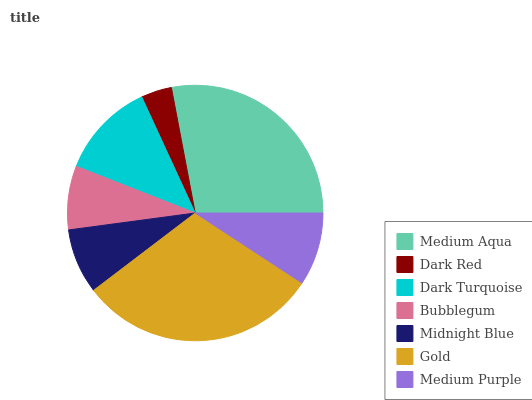Is Dark Red the minimum?
Answer yes or no. Yes. Is Gold the maximum?
Answer yes or no. Yes. Is Dark Turquoise the minimum?
Answer yes or no. No. Is Dark Turquoise the maximum?
Answer yes or no. No. Is Dark Turquoise greater than Dark Red?
Answer yes or no. Yes. Is Dark Red less than Dark Turquoise?
Answer yes or no. Yes. Is Dark Red greater than Dark Turquoise?
Answer yes or no. No. Is Dark Turquoise less than Dark Red?
Answer yes or no. No. Is Medium Purple the high median?
Answer yes or no. Yes. Is Medium Purple the low median?
Answer yes or no. Yes. Is Bubblegum the high median?
Answer yes or no. No. Is Gold the low median?
Answer yes or no. No. 